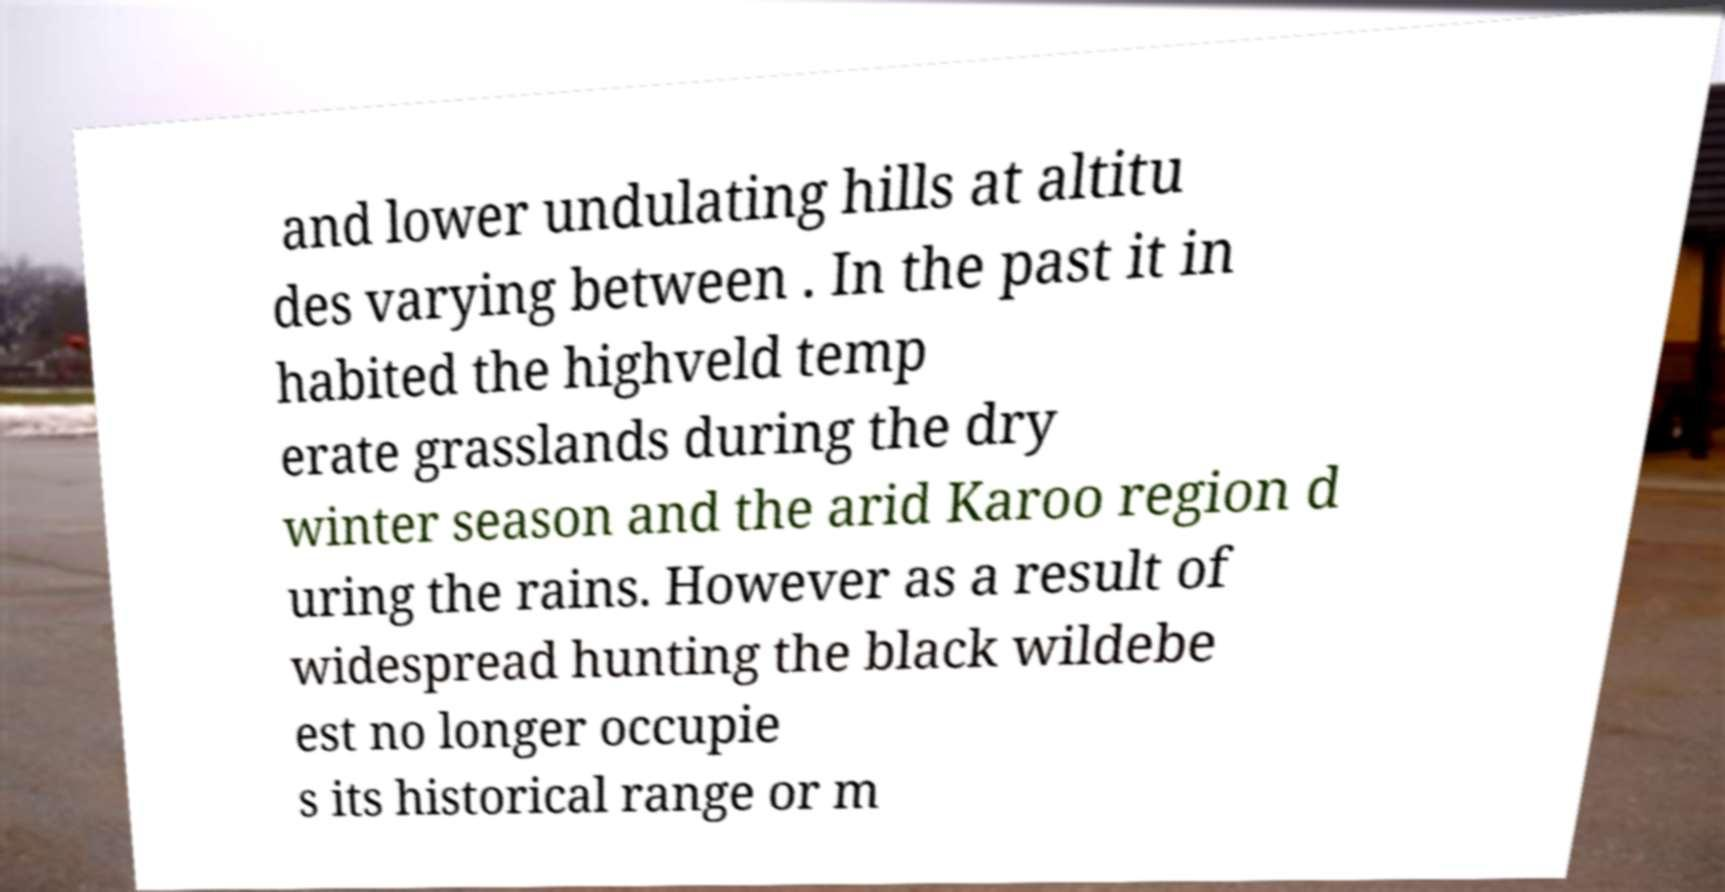Could you extract and type out the text from this image? and lower undulating hills at altitu des varying between . In the past it in habited the highveld temp erate grasslands during the dry winter season and the arid Karoo region d uring the rains. However as a result of widespread hunting the black wildebe est no longer occupie s its historical range or m 